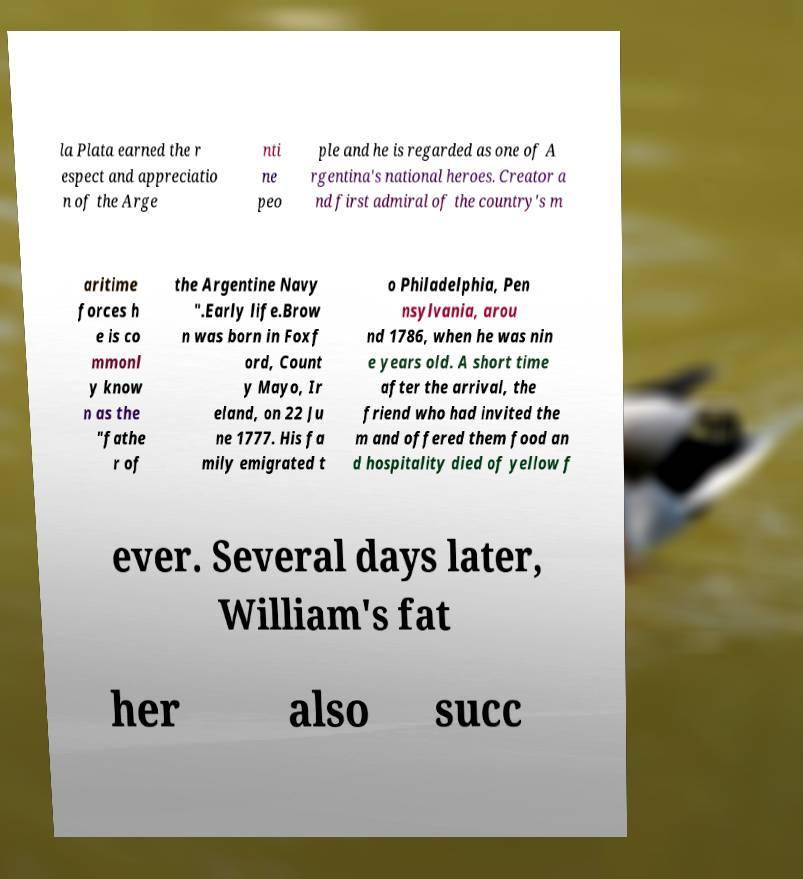Please read and relay the text visible in this image. What does it say? la Plata earned the r espect and appreciatio n of the Arge nti ne peo ple and he is regarded as one of A rgentina's national heroes. Creator a nd first admiral of the country's m aritime forces h e is co mmonl y know n as the "fathe r of the Argentine Navy ".Early life.Brow n was born in Foxf ord, Count y Mayo, Ir eland, on 22 Ju ne 1777. His fa mily emigrated t o Philadelphia, Pen nsylvania, arou nd 1786, when he was nin e years old. A short time after the arrival, the friend who had invited the m and offered them food an d hospitality died of yellow f ever. Several days later, William's fat her also succ 